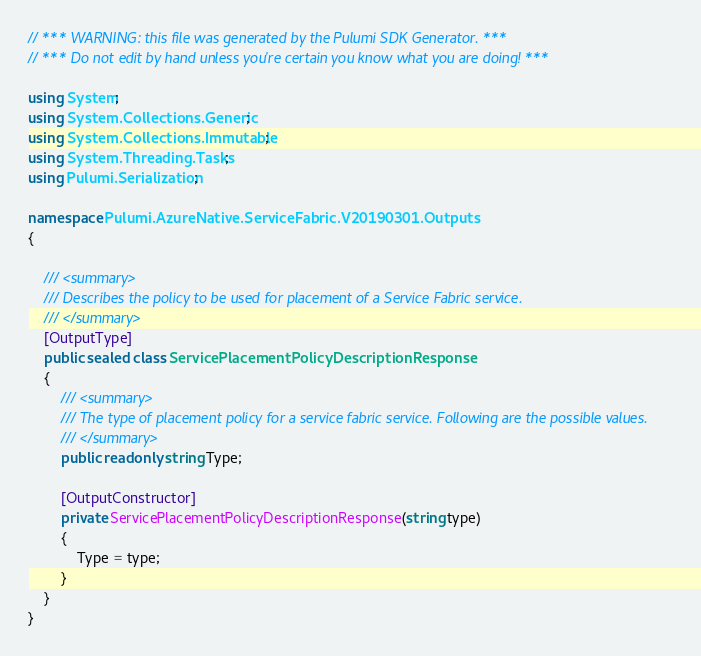<code> <loc_0><loc_0><loc_500><loc_500><_C#_>// *** WARNING: this file was generated by the Pulumi SDK Generator. ***
// *** Do not edit by hand unless you're certain you know what you are doing! ***

using System;
using System.Collections.Generic;
using System.Collections.Immutable;
using System.Threading.Tasks;
using Pulumi.Serialization;

namespace Pulumi.AzureNative.ServiceFabric.V20190301.Outputs
{

    /// <summary>
    /// Describes the policy to be used for placement of a Service Fabric service.
    /// </summary>
    [OutputType]
    public sealed class ServicePlacementPolicyDescriptionResponse
    {
        /// <summary>
        /// The type of placement policy for a service fabric service. Following are the possible values.
        /// </summary>
        public readonly string Type;

        [OutputConstructor]
        private ServicePlacementPolicyDescriptionResponse(string type)
        {
            Type = type;
        }
    }
}
</code> 